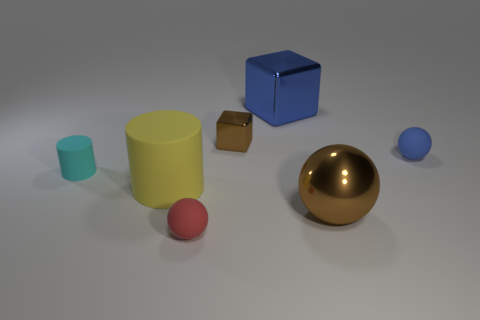There is a thing that is to the left of the large cylinder; does it have the same shape as the tiny matte thing in front of the large matte cylinder?
Your answer should be very brief. No. Are any tiny gray balls visible?
Your answer should be very brief. No. There is another tiny matte object that is the same shape as the tiny blue thing; what color is it?
Your response must be concise. Red. There is a cube that is the same size as the red matte ball; what color is it?
Provide a short and direct response. Brown. Are the tiny cyan cylinder and the tiny red thing made of the same material?
Provide a succinct answer. Yes. How many big blocks are the same color as the small metal object?
Provide a short and direct response. 0. Is the color of the tiny metallic cube the same as the shiny sphere?
Your answer should be very brief. Yes. There is a small sphere right of the tiny red ball; what is it made of?
Your answer should be very brief. Rubber. How many big objects are metal things or metallic balls?
Provide a succinct answer. 2. What material is the thing that is the same color as the small block?
Offer a very short reply. Metal. 